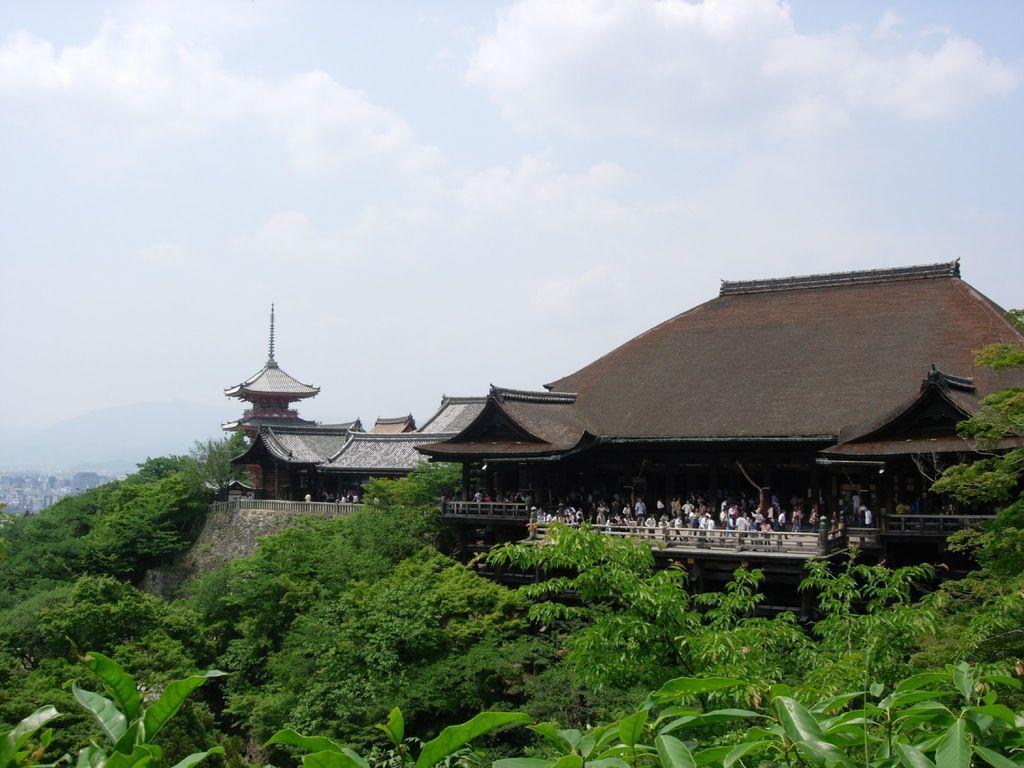Describe this image in one or two sentences. In this picture we can see houses, people and railing. At the bottom of the image, there are trees. At the top of the image, there is the cloudy sky. 